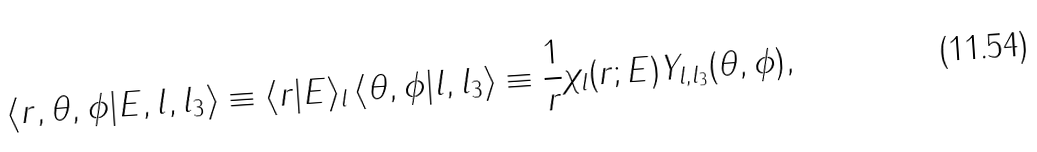<formula> <loc_0><loc_0><loc_500><loc_500>\langle r , \theta , \phi | E , l , l _ { 3 } \rangle \equiv \langle r | E \rangle _ { l } \, \langle \theta , \phi | l , l _ { 3 } \rangle \equiv \frac { 1 } { r } \chi _ { l } ( r ; E ) Y _ { l , l _ { 3 } } ( \theta , \phi ) ,</formula> 